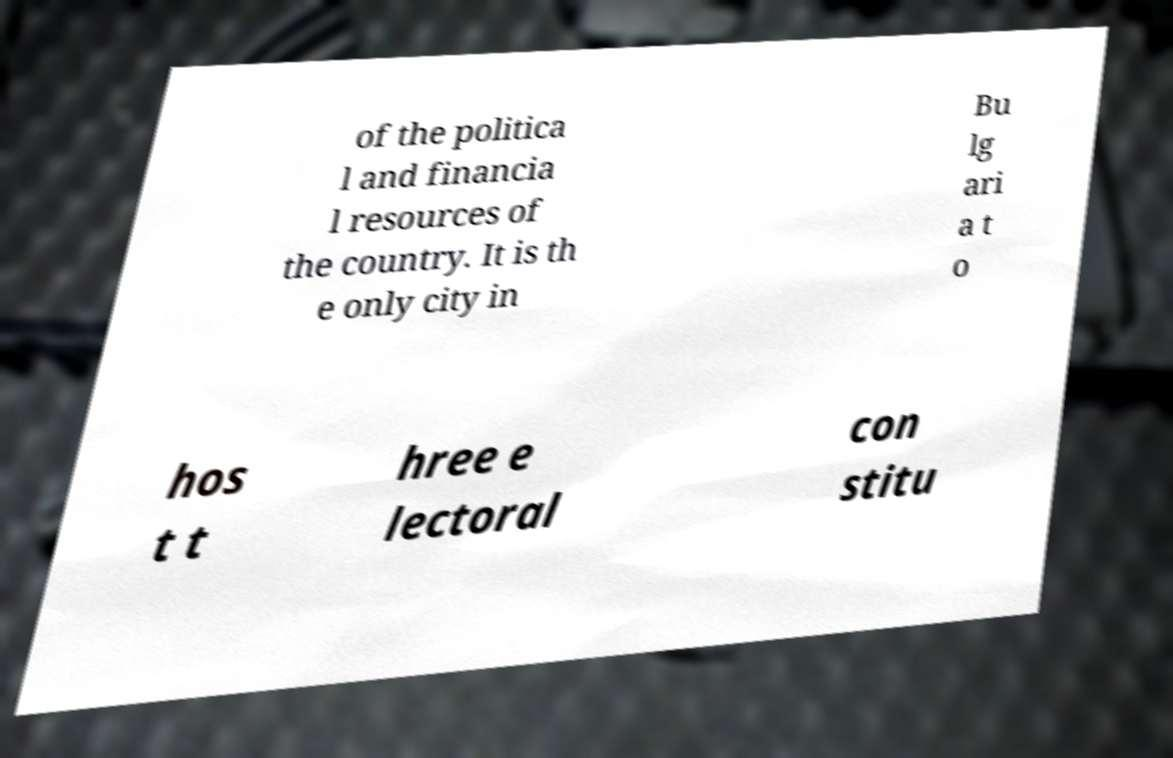Can you read and provide the text displayed in the image?This photo seems to have some interesting text. Can you extract and type it out for me? of the politica l and financia l resources of the country. It is th e only city in Bu lg ari a t o hos t t hree e lectoral con stitu 